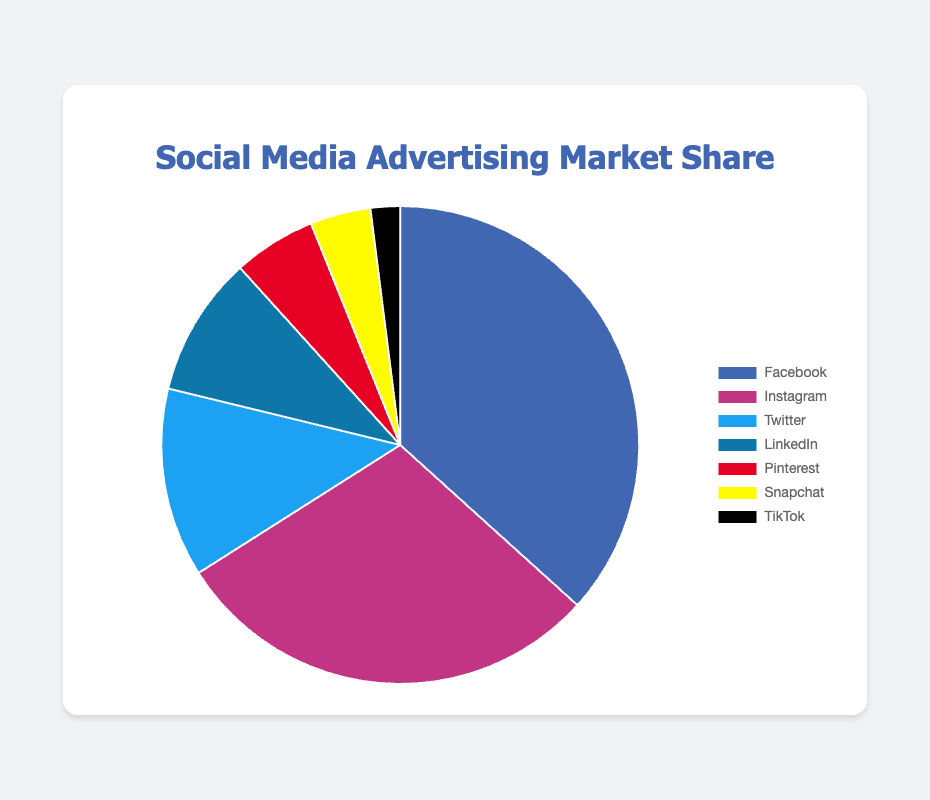What is the total market share percentage of Facebook and Instagram combined? To find the total market share percentage of Facebook and Instagram, add their individual market share percentages: 36.7% (Facebook) + 29.3% (Instagram) = 66.0%
Answer: 66.0% Which social media platform has the smallest market share for advertising? To determine which platform has the smallest market share, identify the platform with the lowest market share percentage. TikTok has the smallest market share at 2.0%
Answer: TikTok How much larger is Facebook's market share compared to Twitter's? Subtract Twitter's market share percentage from Facebook's to find the difference: 36.7% (Facebook) - 12.8% (Twitter) = 23.9%
Answer: 23.9% What is the market share percentage difference between Instagram and LinkedIn? Subtract LinkedIn's market share percentage from Instagram's: 29.3% (Instagram) - 9.5% (LinkedIn) = 19.8%
Answer: 19.8% What is the average market share percentage of the platforms with a share of 10% or less? Identify the platforms with market shares of 10% or less (Twitter, LinkedIn, Pinterest, Snapchat, TikTok) and calculate their average: (12.8% + 9.5% + 5.6% + 4.1% + 2.0%) / 5 = 34.0% / 5 = 6.8%
Answer: 6.8% Which platform has roughly three times the market share of Pinterest? Multiply Pinterest's market share by 3 to find the equivalent: 5.6% * 3 = 16.8%. Since no platform exactly matches 16.8%, identify the closest one. Twitter has 12.8%, which is roughly three times 5.6%
Answer: Twitter If Pinterest and Snapchat combined their market shares, where would they rank in comparison to the other platforms? Add Pinterest and Snapchat's market shares: 5.6% (Pinterest) + 4.1% (Snapchat) = 9.7%. In comparison, this combined share would be higher than LinkedIn (9.5%), making them rank fourth after Twitter (12.8%)
Answer: Fourth Which platform represented by the yellow color has what market share for advertising? Identify the platform represented by yellow in the pie chart: Snapchat. According to the data, Snapchat's market share is 4.1%
Answer: Snapchat Between Facebook, Instagram, and Twitter, which platform has the least market share and by how much compared to the other two? Among Facebook, Instagram, and Twitter, the platform with the least market share is Twitter (12.8%). Facebook has 36.7% and Instagram has 29.3%. The differences are: 36.7% - 12.8% = 23.9% (Facebook vs Twitter), 29.3% - 12.8% = 16.5% (Instagram vs Twitter)
Answer: Twitter, by 23.9% and 16.5% How does LinkedIn's market share compare to Snapchat's, and what is the absolute difference? LinkedIn's market share is 9.5%, while Snapchat's is 4.1%. Subtract to find the absolute difference: 9.5% - 4.1% = 5.4%
Answer: 5.4% 